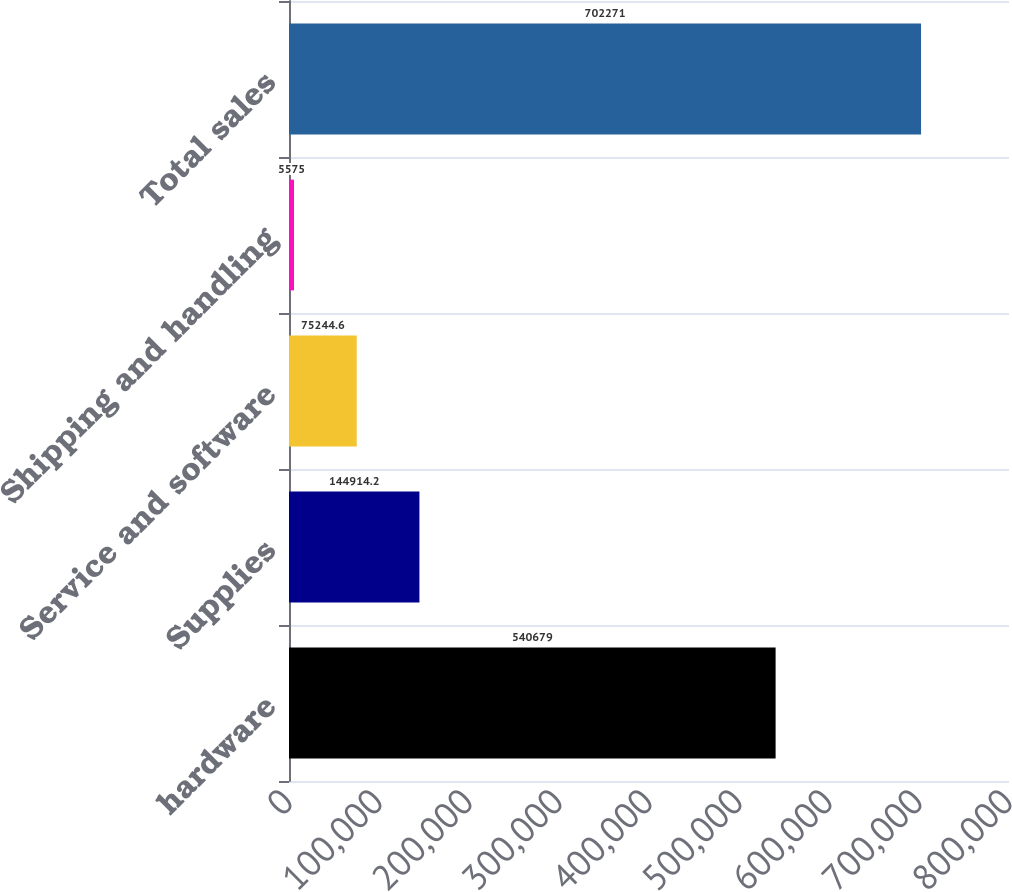Convert chart. <chart><loc_0><loc_0><loc_500><loc_500><bar_chart><fcel>hardware<fcel>Supplies<fcel>Service and software<fcel>Shipping and handling<fcel>Total sales<nl><fcel>540679<fcel>144914<fcel>75244.6<fcel>5575<fcel>702271<nl></chart> 